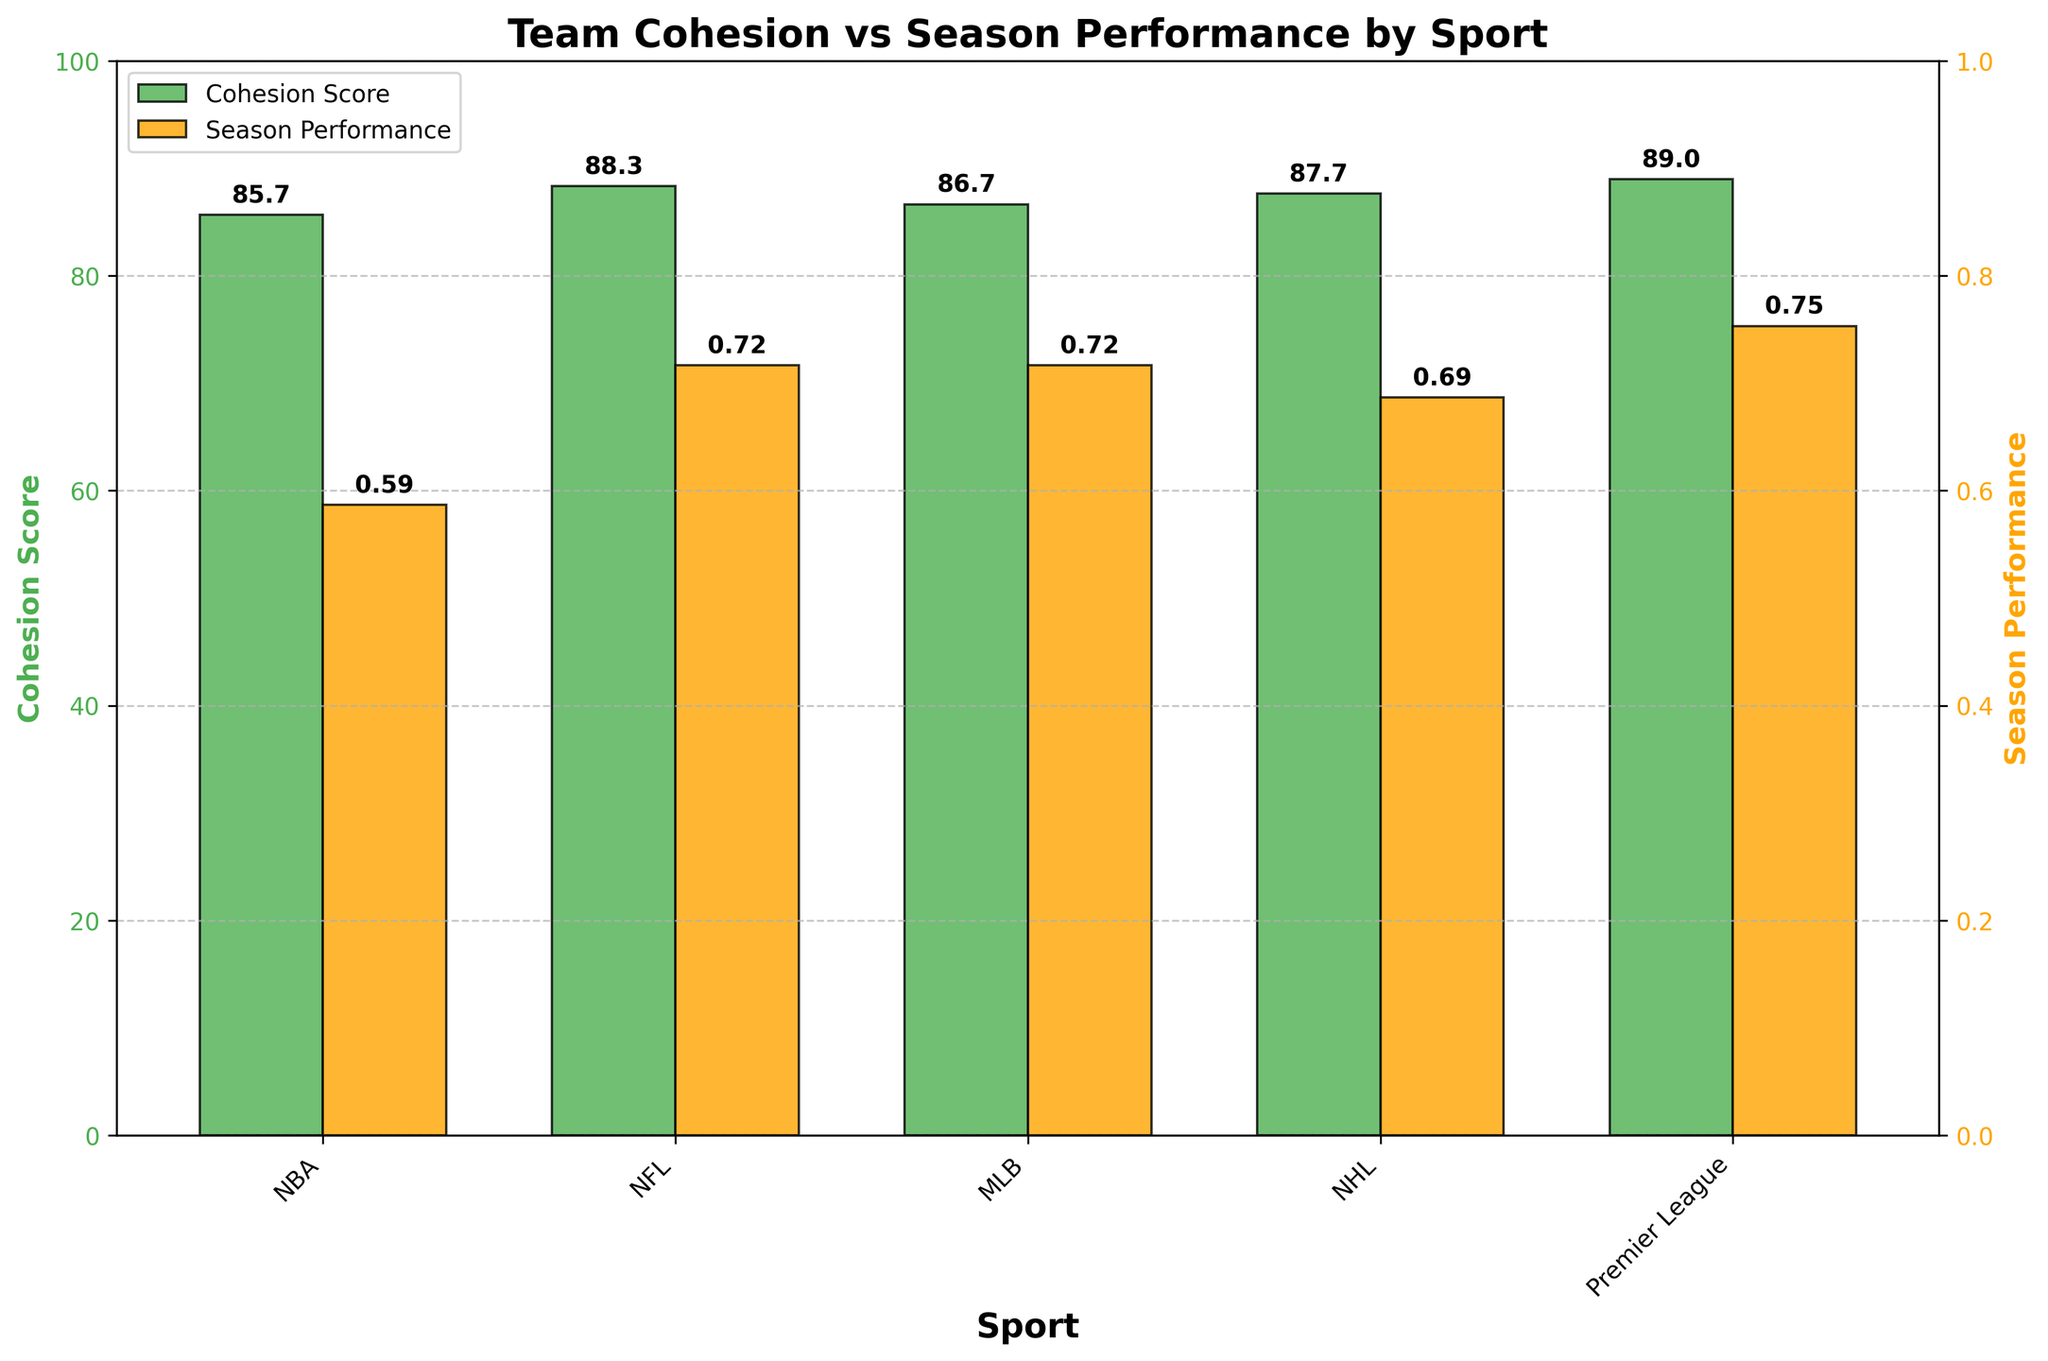Which sport has the highest average cohesion score? By observing the bars representing cohesion scores, we identify that "Premier League" has the tallest green bar representing cohesion scores.
Answer: Premier League Which sport has the lowest average season performance? By examining the heights of the orange bars that represent season performance, the shortest bar is for "MLB," indicating it has the lowest average season performance.
Answer: MLB How do the average cohesion scores of the NHL and NFL compare? Compare the heights of the green bars for NHL and NFL. The green bar for NHL is taller than the green bar for NFL, indicating that the NHL has a higher average cohesion score than the NFL.
Answer: NHL > NFL What is the difference between the cohesion scores and season performance values for NBA teams? Calculate the difference between the average cohesion score (87) and the average season performance score (0.72) for NBA teams, factoring in the scales (100 for cohesion and 1 for performance): difference = 87 - (0.72 * 100) = 87 - 72 = 15.
Answer: 15 Does the NBA have a higher cohesion score than season performance value? Compare the green bar (cohesion score) to the orange bar (season performance value) for the NBA. The green bar is taller, indicating the cohesion score is higher than the season performance value.
Answer: Yes Between NFL and MLB, which sport has a higher average season performance? Compare the heights of the orange bars for NFL and MLB. The orange bar for NFL is taller, indicating NFL has a higher average season performance.
Answer: NFL On average, how does the cohesion score of Premier League teams compare to the cohesion score of NHL teams? By observing the green bars, the one for the Premier League is taller than the one for the NHL, indicating the Premier League cohesion score is higher.
Answer: Premier League > NHL What is the visual difference between the cohesion scores and season performance in the NHL? In the NHL, the green bar (cohesion score) is significantly taller than the orange bar (season performance), indicating a notable difference with higher cohesion scores.
Answer: Cohesion score is significantly higher Compare the cohesion scores and season performance for the NBA and NFL. Which sport shows a larger difference between these two metrics? Calculate the difference for each sport: 
NBA: 87 (cohesion) - 72 (performance) = 15, 
NFL: 86.67 (cohesion) - 71.67 (performance) = 15. 
Both sports show the same difference.
Answer: Both show a difference of 15 Which sport has a closer match between cohesion scores and season performance values? Observe which pairs of green and orange bars are closest in height. The bars for Premier League are closest in height, meaning its cohesion score and season performance values are more closely matched.
Answer: Premier League 